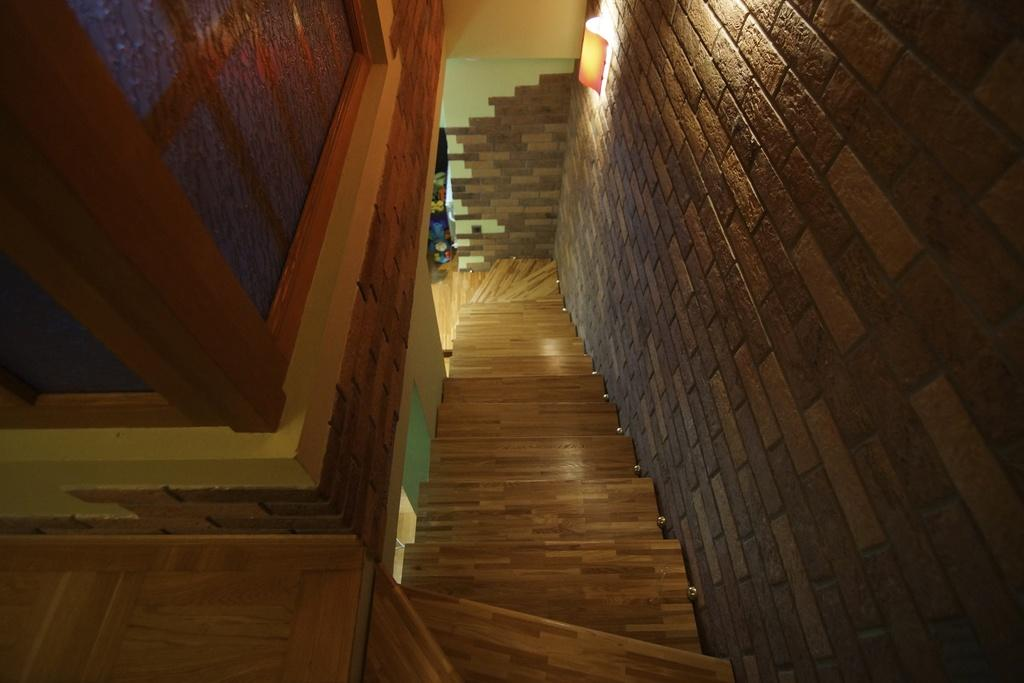What type of location is depicted in the image? The image shows an inner view of a building. What can be seen in the middle of the image? There is a staircase in the middle of the image. Is there any source of illumination in the image? Yes, a light is attached to the wall in the image. How many bubbles are floating near the staircase in the image? There are no bubbles present in the image. What type of sponge is being used to clean the light in the image? There is no sponge visible in the image, and the light is not being cleaned. 